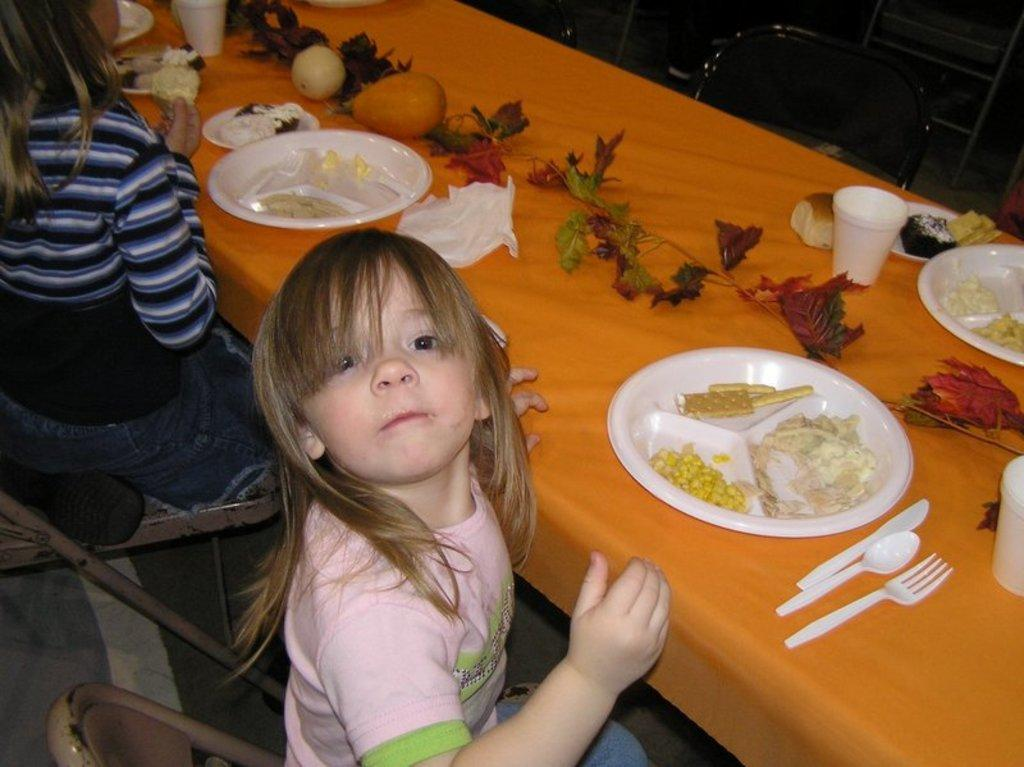Who is the main subject in the image? There is a girl in the image. What is the girl doing in the image? The girl is sitting on a chair. What is located near the girl in the image? There is a table in the image. What is on the table in the image? There is a plate on the table, and there is a food item on the plate. What utensils are present on the table in the image? There are fork and knife on the table. What type of slope can be seen in the image? There is no slope present in the image. How many yards are visible in the image? There is no yard present in the image. 